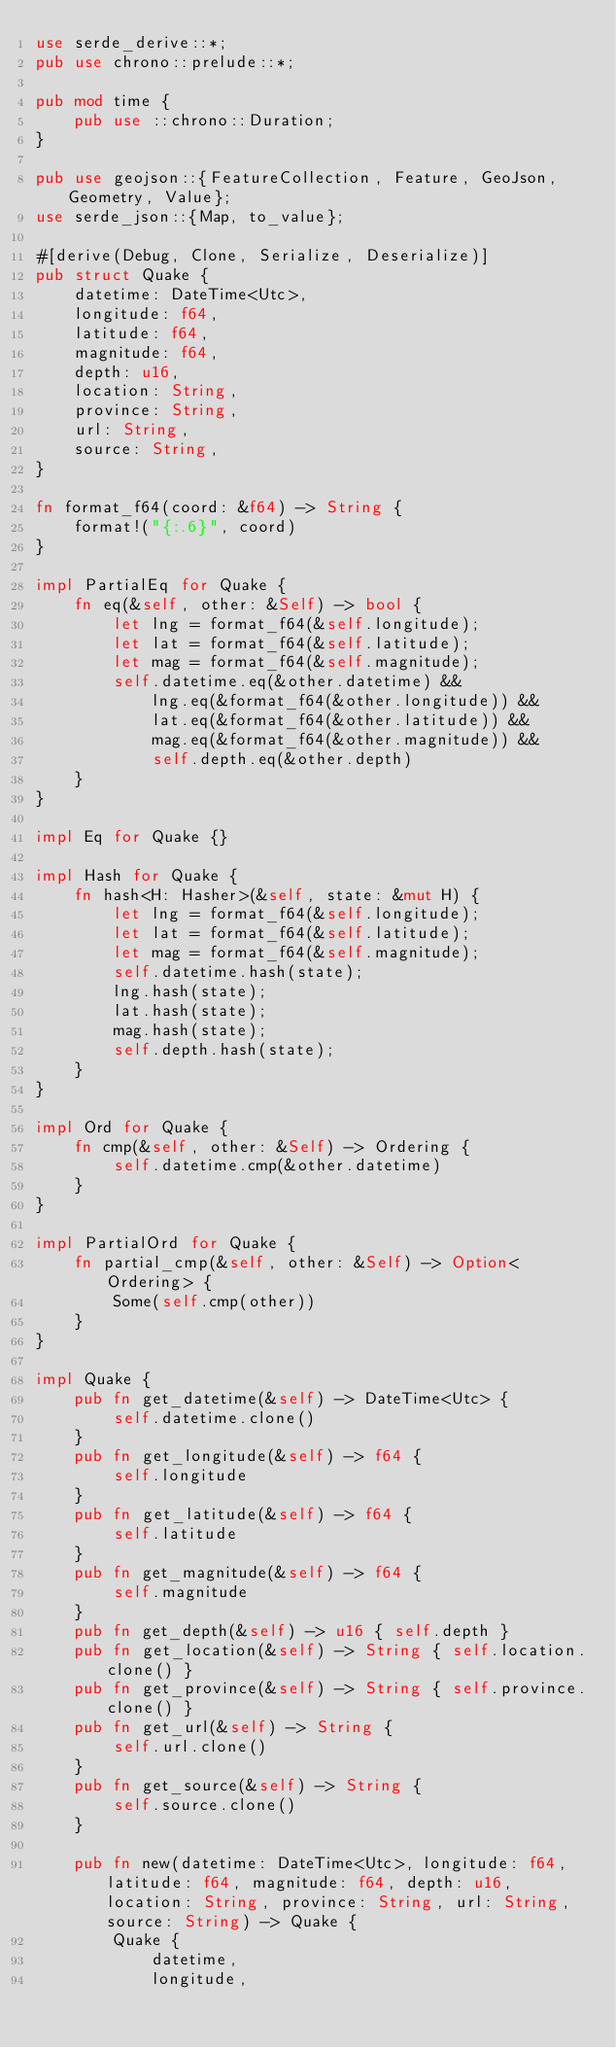<code> <loc_0><loc_0><loc_500><loc_500><_Rust_>use serde_derive::*;
pub use chrono::prelude::*;

pub mod time {
    pub use ::chrono::Duration;
}

pub use geojson::{FeatureCollection, Feature, GeoJson, Geometry, Value};
use serde_json::{Map, to_value};

#[derive(Debug, Clone, Serialize, Deserialize)]
pub struct Quake {
    datetime: DateTime<Utc>,
    longitude: f64,
    latitude: f64,
    magnitude: f64,
    depth: u16,
    location: String,
    province: String,
    url: String,
    source: String,
}

fn format_f64(coord: &f64) -> String {
    format!("{:.6}", coord)
}

impl PartialEq for Quake {
    fn eq(&self, other: &Self) -> bool {
        let lng = format_f64(&self.longitude);
        let lat = format_f64(&self.latitude);
        let mag = format_f64(&self.magnitude);
        self.datetime.eq(&other.datetime) &&
            lng.eq(&format_f64(&other.longitude)) &&
            lat.eq(&format_f64(&other.latitude)) &&
            mag.eq(&format_f64(&other.magnitude)) &&
            self.depth.eq(&other.depth)
    }
}

impl Eq for Quake {}

impl Hash for Quake {
    fn hash<H: Hasher>(&self, state: &mut H) {
        let lng = format_f64(&self.longitude);
        let lat = format_f64(&self.latitude);
        let mag = format_f64(&self.magnitude);
        self.datetime.hash(state);
        lng.hash(state);
        lat.hash(state);
        mag.hash(state);
        self.depth.hash(state);
    }
}

impl Ord for Quake {
    fn cmp(&self, other: &Self) -> Ordering {
        self.datetime.cmp(&other.datetime)
    }
}

impl PartialOrd for Quake {
    fn partial_cmp(&self, other: &Self) -> Option<Ordering> {
        Some(self.cmp(other))
    }
}

impl Quake {
    pub fn get_datetime(&self) -> DateTime<Utc> {
        self.datetime.clone()
    }
    pub fn get_longitude(&self) -> f64 {
        self.longitude
    }
    pub fn get_latitude(&self) -> f64 {
        self.latitude
    }
    pub fn get_magnitude(&self) -> f64 {
        self.magnitude
    }
    pub fn get_depth(&self) -> u16 { self.depth }
    pub fn get_location(&self) -> String { self.location.clone() }
    pub fn get_province(&self) -> String { self.province.clone() }
    pub fn get_url(&self) -> String {
        self.url.clone()
    }
    pub fn get_source(&self) -> String {
        self.source.clone()
    }

    pub fn new(datetime: DateTime<Utc>, longitude: f64, latitude: f64, magnitude: f64, depth: u16, location: String, province: String, url: String, source: String) -> Quake {
        Quake {
            datetime,
            longitude,</code> 